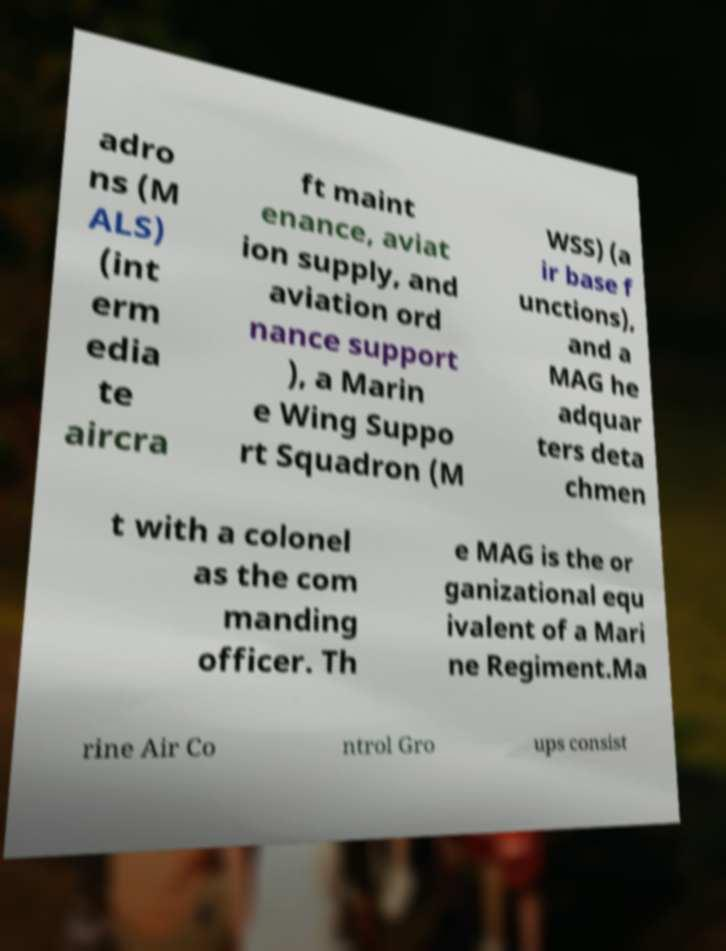What messages or text are displayed in this image? I need them in a readable, typed format. adro ns (M ALS) (int erm edia te aircra ft maint enance, aviat ion supply, and aviation ord nance support ), a Marin e Wing Suppo rt Squadron (M WSS) (a ir base f unctions), and a MAG he adquar ters deta chmen t with a colonel as the com manding officer. Th e MAG is the or ganizational equ ivalent of a Mari ne Regiment.Ma rine Air Co ntrol Gro ups consist 